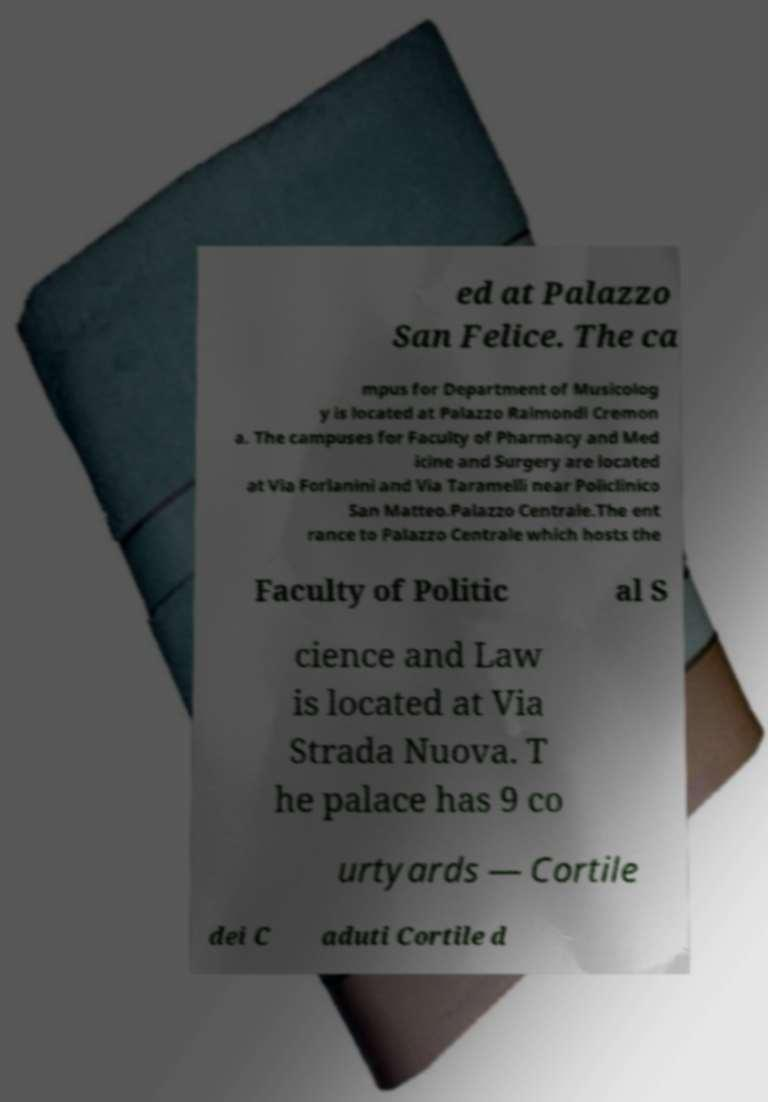Could you extract and type out the text from this image? ed at Palazzo San Felice. The ca mpus for Department of Musicolog y is located at Palazzo Raimondi Cremon a. The campuses for Faculty of Pharmacy and Med icine and Surgery are located at Via Forlanini and Via Taramelli near Policlinico San Matteo.Palazzo Centrale.The ent rance to Palazzo Centrale which hosts the Faculty of Politic al S cience and Law is located at Via Strada Nuova. T he palace has 9 co urtyards — Cortile dei C aduti Cortile d 